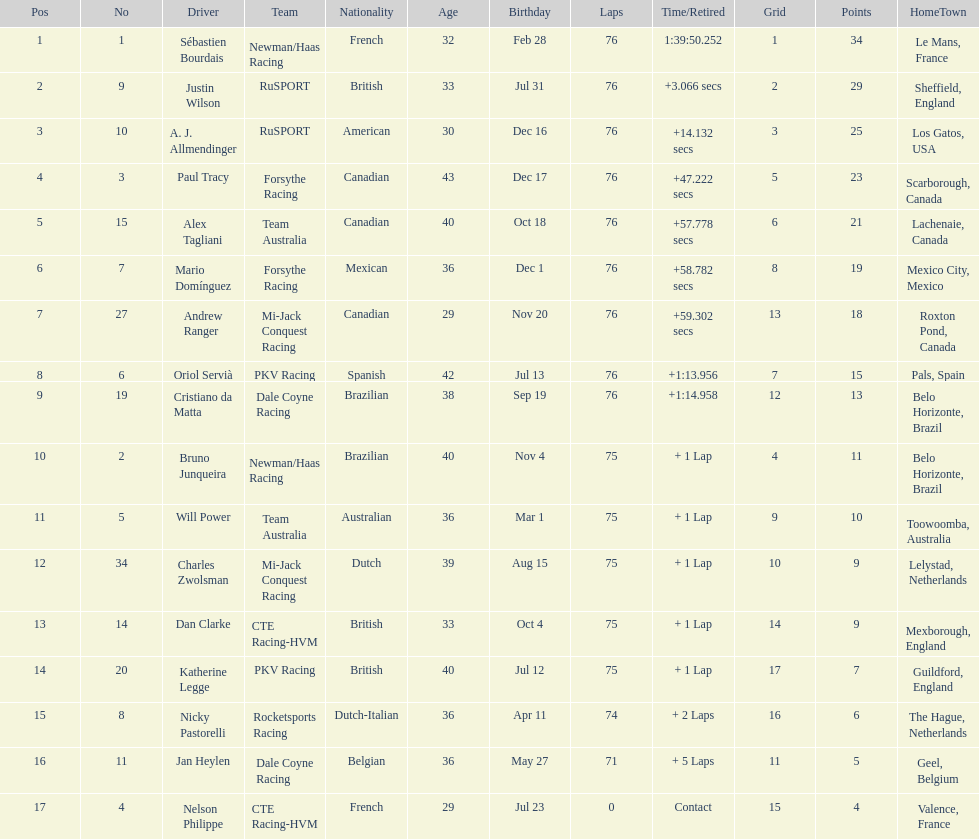Charles zwolsman acquired the same number of points as who? Dan Clarke. 